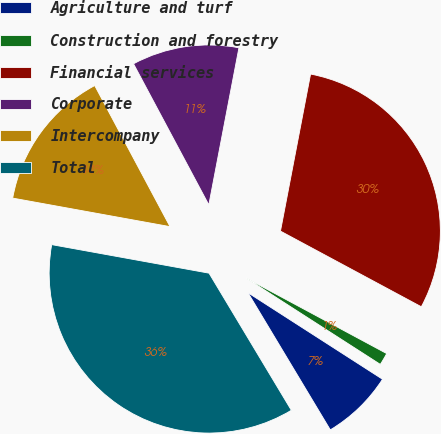Convert chart to OTSL. <chart><loc_0><loc_0><loc_500><loc_500><pie_chart><fcel>Agriculture and turf<fcel>Construction and forestry<fcel>Financial services<fcel>Corporate<fcel>Intercompany<fcel>Total<nl><fcel>7.3%<fcel>1.25%<fcel>29.83%<fcel>10.82%<fcel>14.34%<fcel>36.46%<nl></chart> 